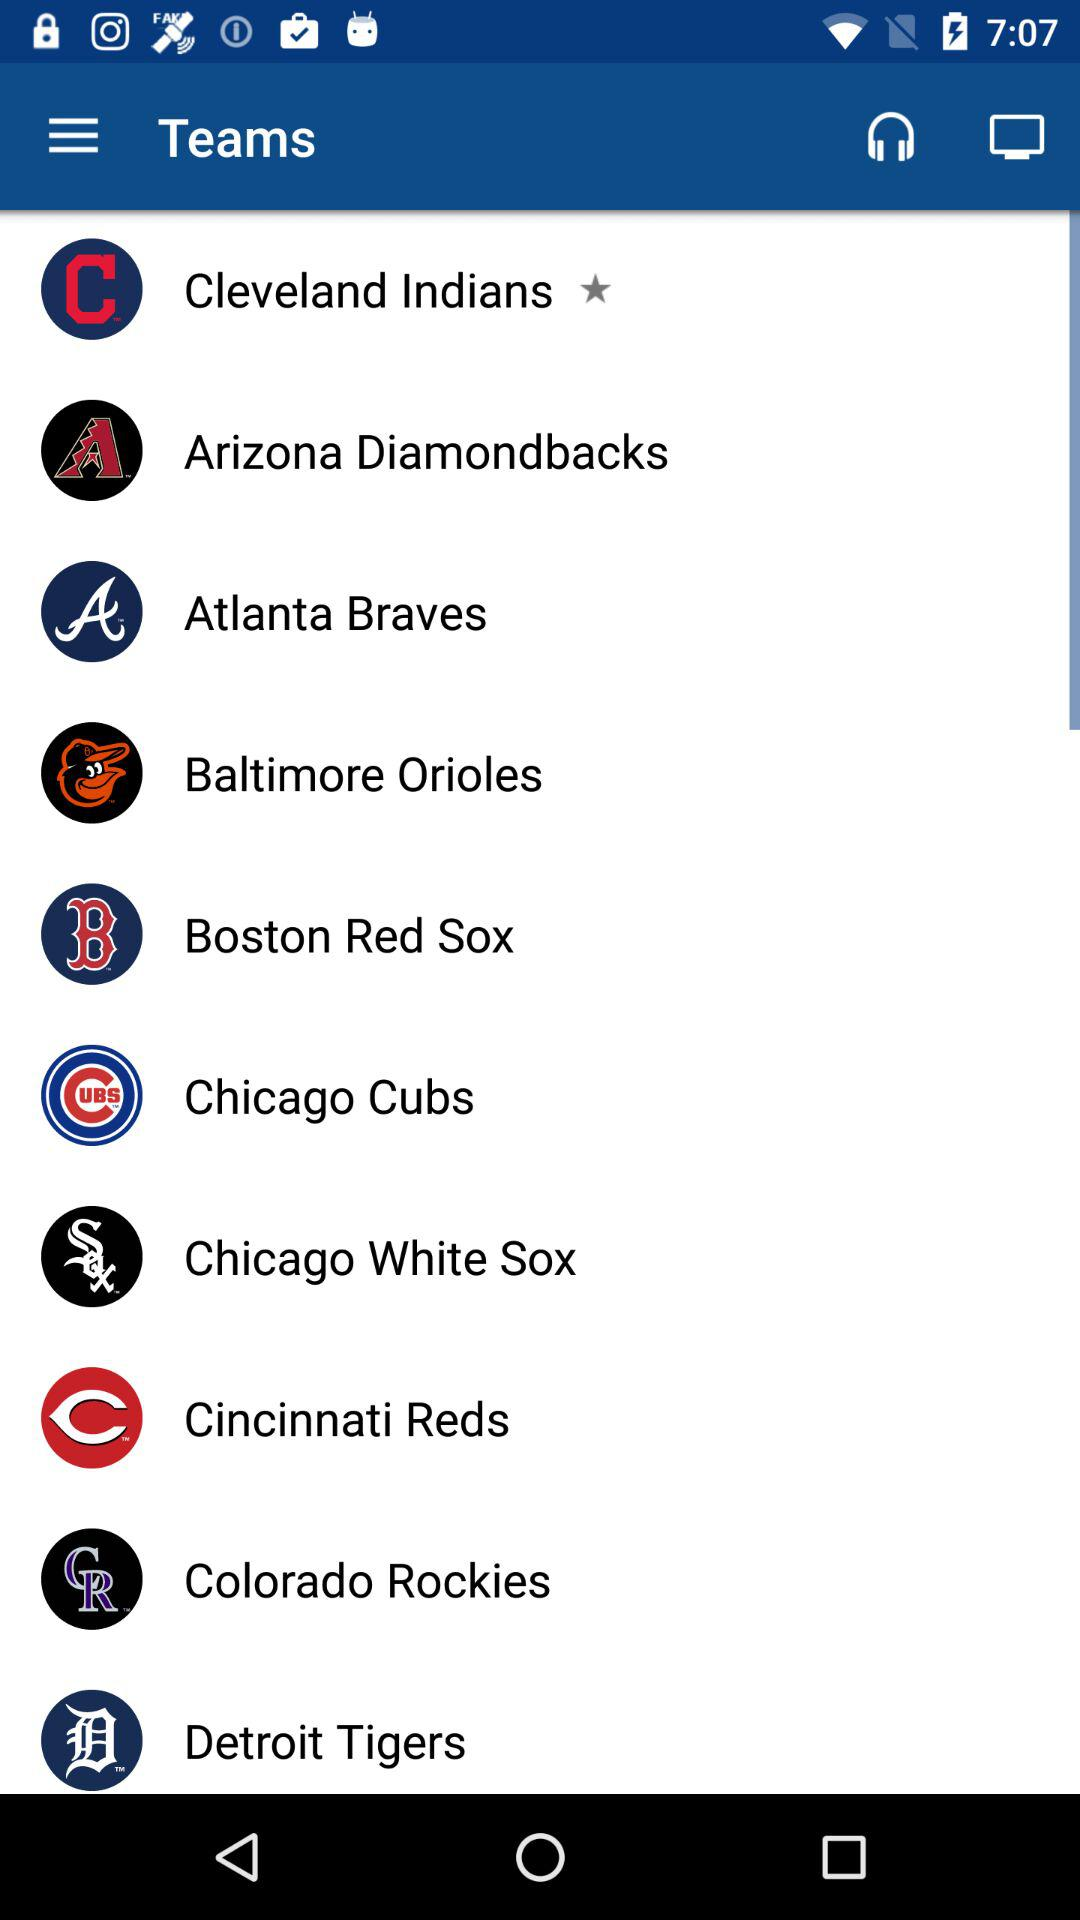Which are the different teams? The different teams are "Cleveland Indians", "Arizona Diamondbacks", "Atlanta Braves", "Baltimore Orioles", "Boston Red Sox", "Chicago Cubs", "Chicago White Sox", "Cincinnati Reds", "Colorado Rockies" and "Detroit Tigers". 